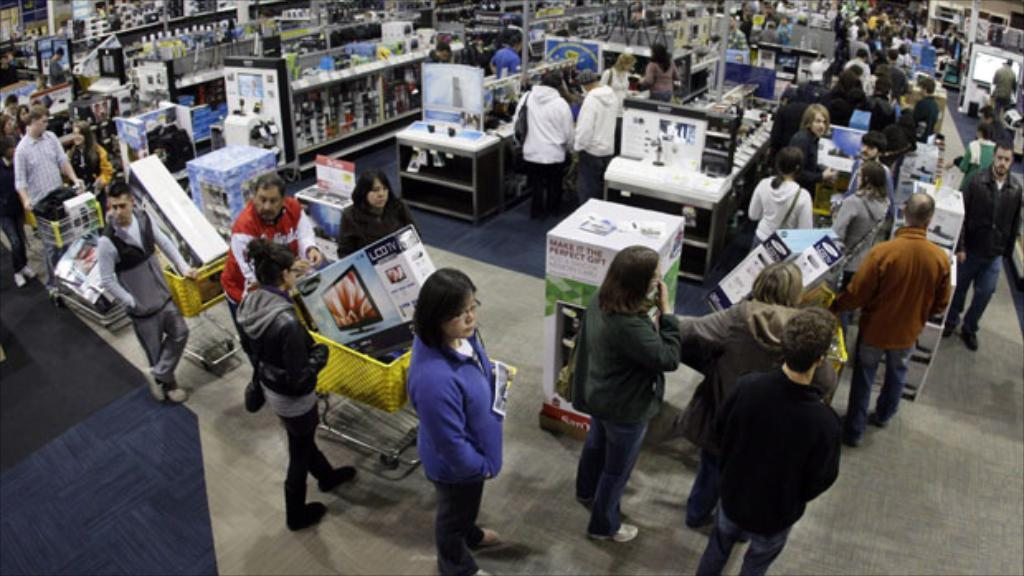How many people are in the group visible in the image? There is a group of people standing in the image, but the exact number cannot be determined from the provided facts. What type of transportation is present in the image? There are trolleys in the image. What other objects can be seen in the image besides the trolleys? There are cardboard boxes and some other objects in the image. Can you see a goose swinging on a needle in the image? No, there is no goose, swing, or needle present in the image. 